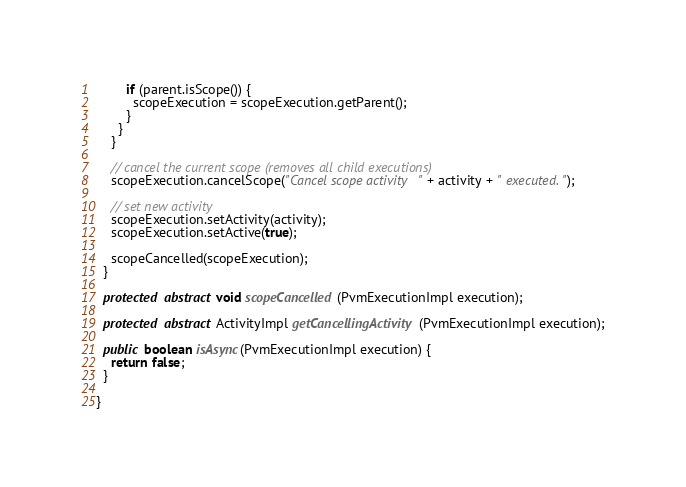<code> <loc_0><loc_0><loc_500><loc_500><_Java_>
        if (parent.isScope()) {
          scopeExecution = scopeExecution.getParent();
        }
      }
    }

    // cancel the current scope (removes all child executions)
    scopeExecution.cancelScope("Cancel scope activity " + activity + " executed.");

    // set new activity
    scopeExecution.setActivity(activity);
    scopeExecution.setActive(true);

    scopeCancelled(scopeExecution);
  }

  protected abstract void scopeCancelled(PvmExecutionImpl execution);

  protected abstract ActivityImpl getCancellingActivity(PvmExecutionImpl execution);

  public boolean isAsync(PvmExecutionImpl execution) {
    return false;
  }

}
</code> 